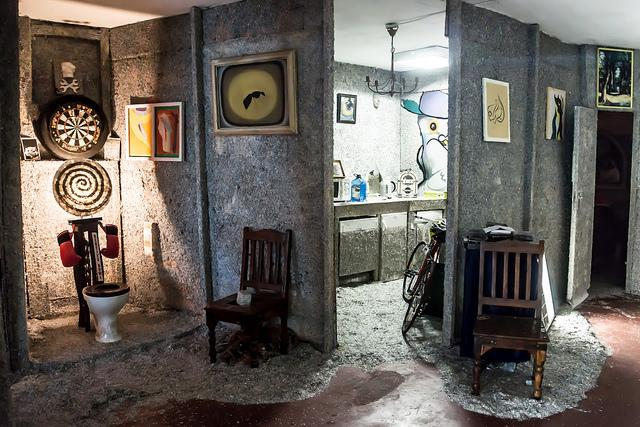Who most likely lives here? artist 